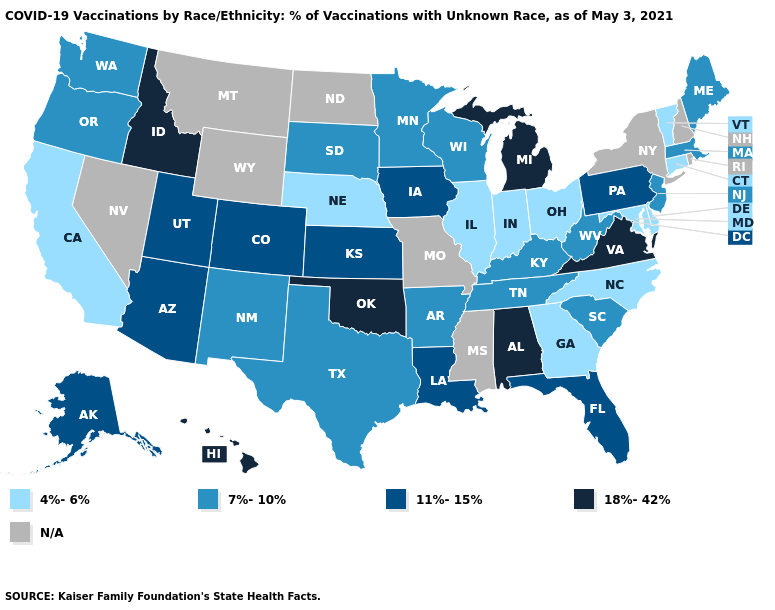Name the states that have a value in the range 4%-6%?
Answer briefly. California, Connecticut, Delaware, Georgia, Illinois, Indiana, Maryland, Nebraska, North Carolina, Ohio, Vermont. Among the states that border Tennessee , does Arkansas have the highest value?
Quick response, please. No. Which states have the highest value in the USA?
Concise answer only. Alabama, Hawaii, Idaho, Michigan, Oklahoma, Virginia. Is the legend a continuous bar?
Short answer required. No. Name the states that have a value in the range 4%-6%?
Be succinct. California, Connecticut, Delaware, Georgia, Illinois, Indiana, Maryland, Nebraska, North Carolina, Ohio, Vermont. Among the states that border Delaware , does Maryland have the highest value?
Short answer required. No. What is the value of Montana?
Answer briefly. N/A. Name the states that have a value in the range 18%-42%?
Quick response, please. Alabama, Hawaii, Idaho, Michigan, Oklahoma, Virginia. How many symbols are there in the legend?
Write a very short answer. 5. What is the value of Oregon?
Be succinct. 7%-10%. Name the states that have a value in the range 7%-10%?
Answer briefly. Arkansas, Kentucky, Maine, Massachusetts, Minnesota, New Jersey, New Mexico, Oregon, South Carolina, South Dakota, Tennessee, Texas, Washington, West Virginia, Wisconsin. What is the highest value in the USA?
Concise answer only. 18%-42%. What is the value of Arizona?
Write a very short answer. 11%-15%. 